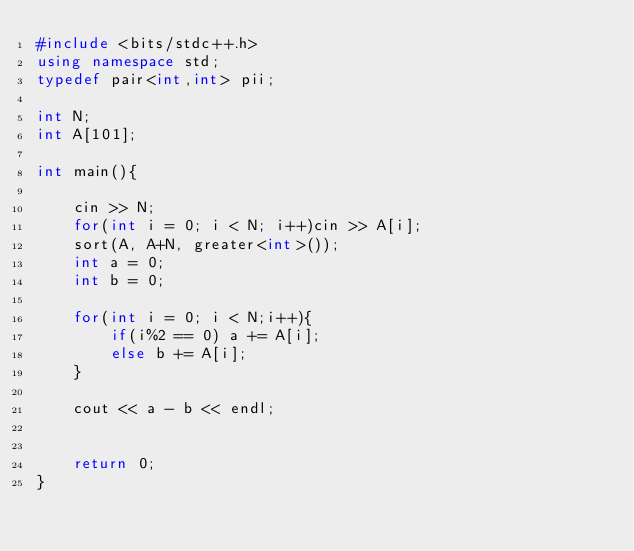<code> <loc_0><loc_0><loc_500><loc_500><_C++_>#include <bits/stdc++.h>
using namespace std;
typedef pair<int,int> pii;

int N;
int A[101];

int main(){

    cin >> N;
    for(int i = 0; i < N; i++)cin >> A[i];
    sort(A, A+N, greater<int>());
    int a = 0;
    int b = 0;

    for(int i = 0; i < N;i++){
        if(i%2 == 0) a += A[i];
        else b += A[i];
    }

    cout << a - b << endl;
    

    return 0;
}
</code> 